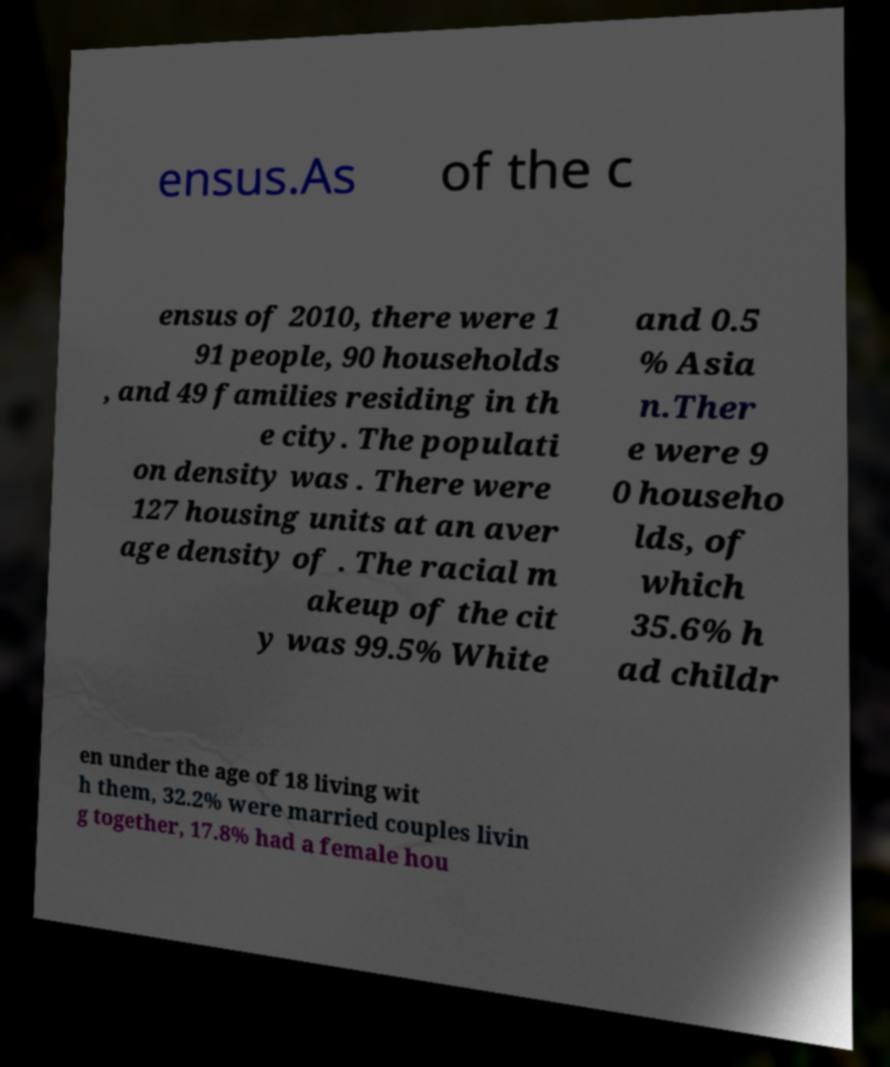Could you extract and type out the text from this image? ensus.As of the c ensus of 2010, there were 1 91 people, 90 households , and 49 families residing in th e city. The populati on density was . There were 127 housing units at an aver age density of . The racial m akeup of the cit y was 99.5% White and 0.5 % Asia n.Ther e were 9 0 househo lds, of which 35.6% h ad childr en under the age of 18 living wit h them, 32.2% were married couples livin g together, 17.8% had a female hou 